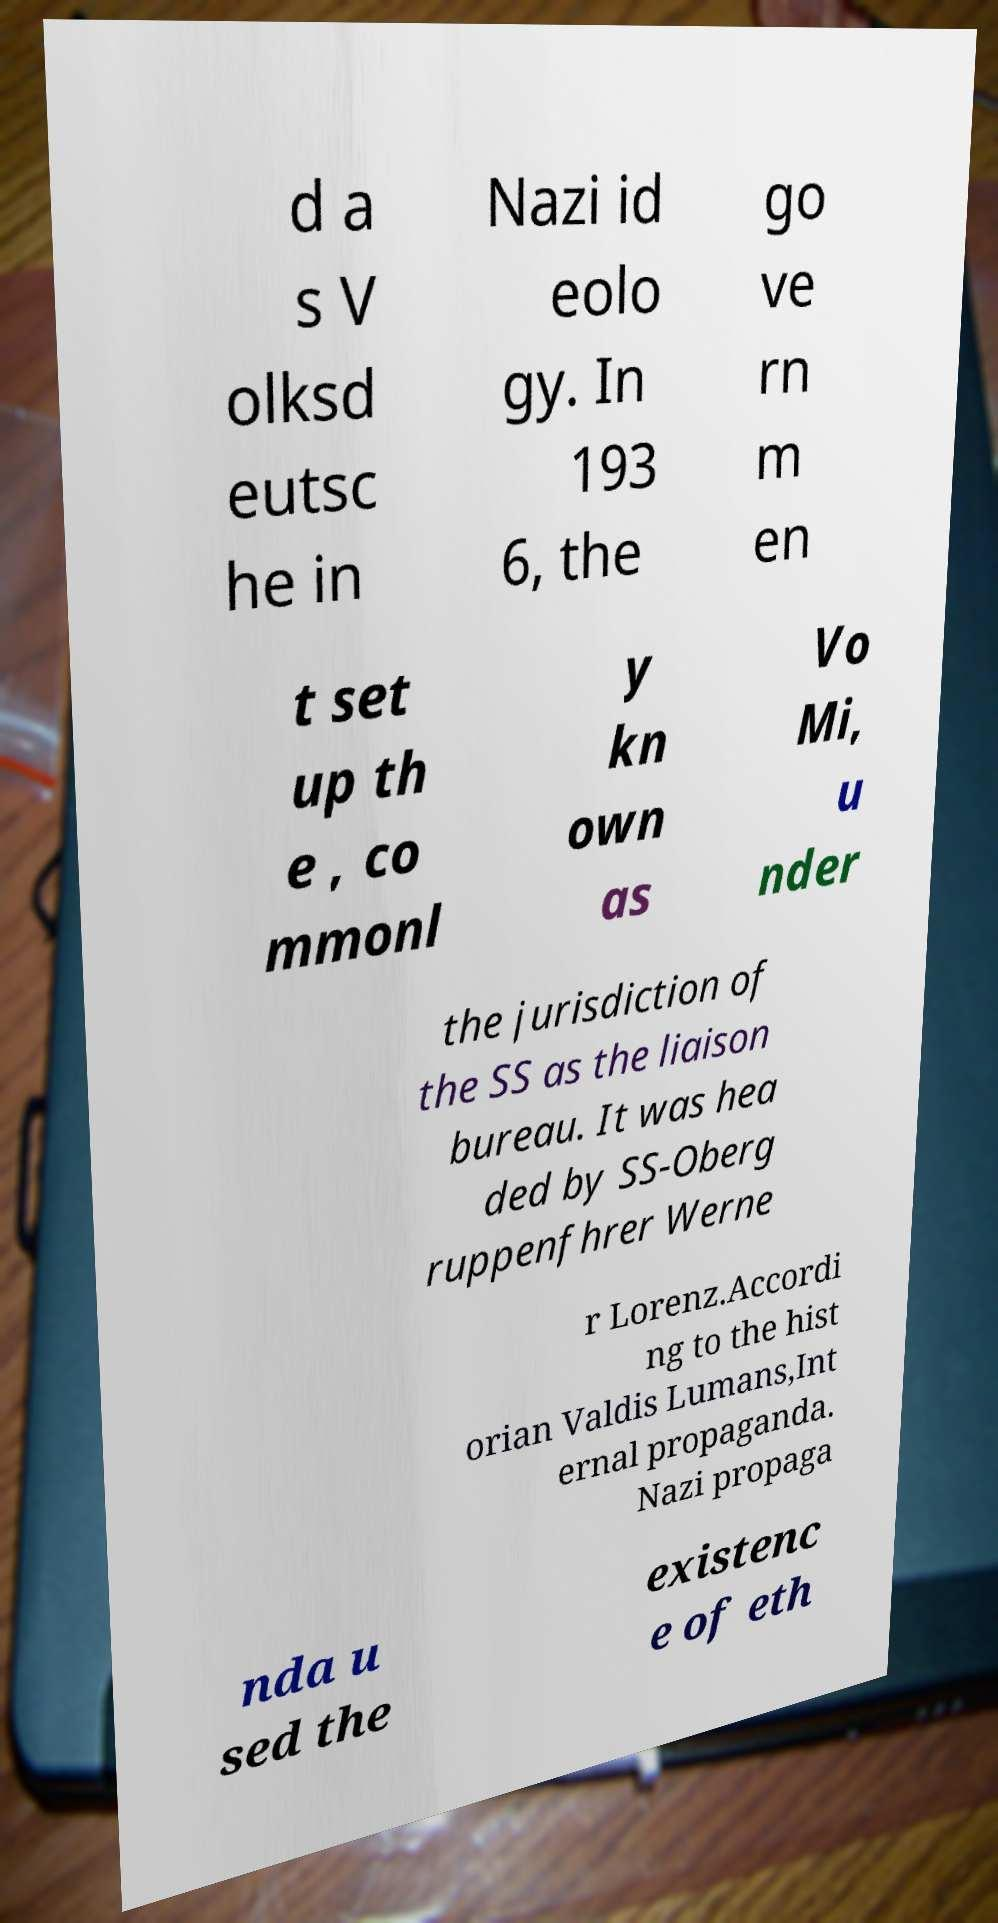What messages or text are displayed in this image? I need them in a readable, typed format. d a s V olksd eutsc he in Nazi id eolo gy. In 193 6, the go ve rn m en t set up th e , co mmonl y kn own as Vo Mi, u nder the jurisdiction of the SS as the liaison bureau. It was hea ded by SS-Oberg ruppenfhrer Werne r Lorenz.Accordi ng to the hist orian Valdis Lumans,Int ernal propaganda. Nazi propaga nda u sed the existenc e of eth 